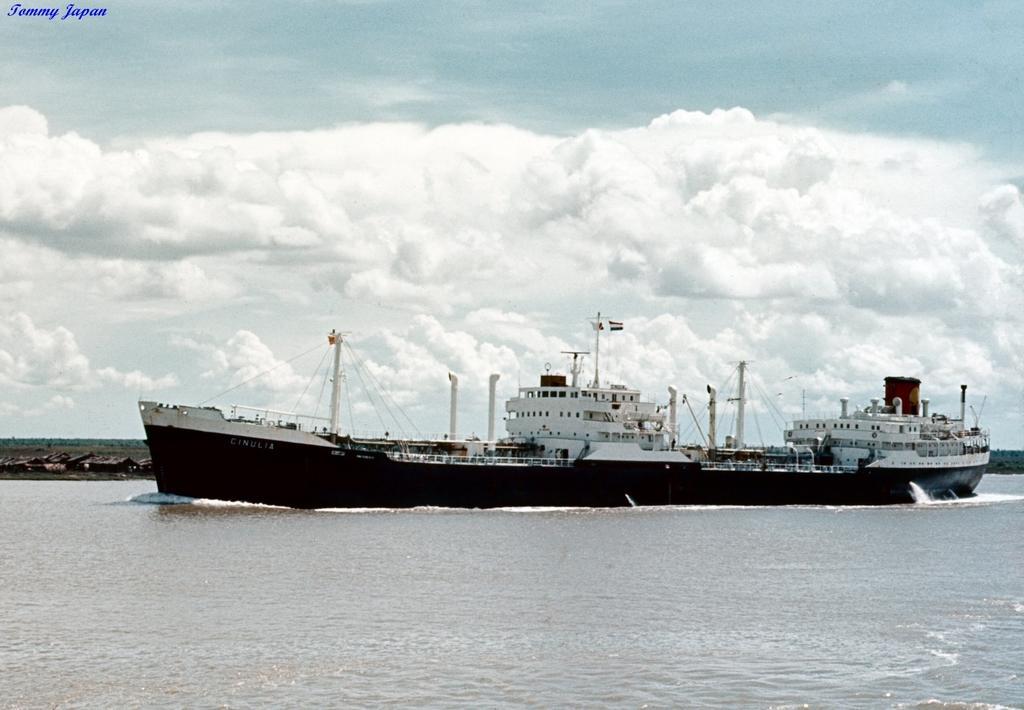In one or two sentences, can you explain what this image depicts? In this image I can see water and in it I can see black colour ship. I can also see few wires and in the background I can see clouds and the sky. 